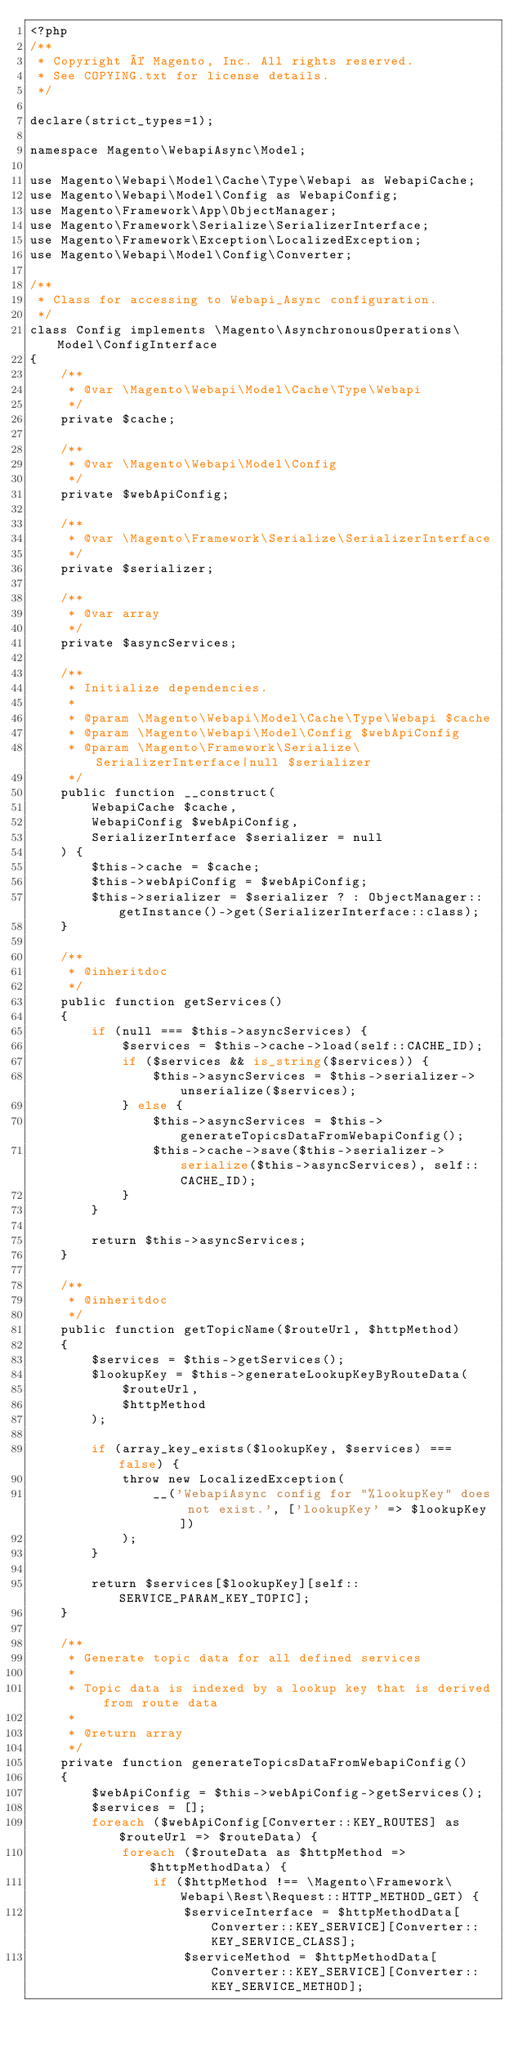<code> <loc_0><loc_0><loc_500><loc_500><_PHP_><?php
/**
 * Copyright © Magento, Inc. All rights reserved.
 * See COPYING.txt for license details.
 */

declare(strict_types=1);

namespace Magento\WebapiAsync\Model;

use Magento\Webapi\Model\Cache\Type\Webapi as WebapiCache;
use Magento\Webapi\Model\Config as WebapiConfig;
use Magento\Framework\App\ObjectManager;
use Magento\Framework\Serialize\SerializerInterface;
use Magento\Framework\Exception\LocalizedException;
use Magento\Webapi\Model\Config\Converter;

/**
 * Class for accessing to Webapi_Async configuration.
 */
class Config implements \Magento\AsynchronousOperations\Model\ConfigInterface
{
    /**
     * @var \Magento\Webapi\Model\Cache\Type\Webapi
     */
    private $cache;

    /**
     * @var \Magento\Webapi\Model\Config
     */
    private $webApiConfig;

    /**
     * @var \Magento\Framework\Serialize\SerializerInterface
     */
    private $serializer;

    /**
     * @var array
     */
    private $asyncServices;

    /**
     * Initialize dependencies.
     *
     * @param \Magento\Webapi\Model\Cache\Type\Webapi $cache
     * @param \Magento\Webapi\Model\Config $webApiConfig
     * @param \Magento\Framework\Serialize\SerializerInterface|null $serializer
     */
    public function __construct(
        WebapiCache $cache,
        WebapiConfig $webApiConfig,
        SerializerInterface $serializer = null
    ) {
        $this->cache = $cache;
        $this->webApiConfig = $webApiConfig;
        $this->serializer = $serializer ? : ObjectManager::getInstance()->get(SerializerInterface::class);
    }

    /**
     * @inheritdoc
     */
    public function getServices()
    {
        if (null === $this->asyncServices) {
            $services = $this->cache->load(self::CACHE_ID);
            if ($services && is_string($services)) {
                $this->asyncServices = $this->serializer->unserialize($services);
            } else {
                $this->asyncServices = $this->generateTopicsDataFromWebapiConfig();
                $this->cache->save($this->serializer->serialize($this->asyncServices), self::CACHE_ID);
            }
        }

        return $this->asyncServices;
    }

    /**
     * @inheritdoc
     */
    public function getTopicName($routeUrl, $httpMethod)
    {
        $services = $this->getServices();
        $lookupKey = $this->generateLookupKeyByRouteData(
            $routeUrl,
            $httpMethod
        );

        if (array_key_exists($lookupKey, $services) === false) {
            throw new LocalizedException(
                __('WebapiAsync config for "%lookupKey" does not exist.', ['lookupKey' => $lookupKey])
            );
        }

        return $services[$lookupKey][self::SERVICE_PARAM_KEY_TOPIC];
    }

    /**
     * Generate topic data for all defined services
     *
     * Topic data is indexed by a lookup key that is derived from route data
     *
     * @return array
     */
    private function generateTopicsDataFromWebapiConfig()
    {
        $webApiConfig = $this->webApiConfig->getServices();
        $services = [];
        foreach ($webApiConfig[Converter::KEY_ROUTES] as $routeUrl => $routeData) {
            foreach ($routeData as $httpMethod => $httpMethodData) {
                if ($httpMethod !== \Magento\Framework\Webapi\Rest\Request::HTTP_METHOD_GET) {
                    $serviceInterface = $httpMethodData[Converter::KEY_SERVICE][Converter::KEY_SERVICE_CLASS];
                    $serviceMethod = $httpMethodData[Converter::KEY_SERVICE][Converter::KEY_SERVICE_METHOD];
</code> 